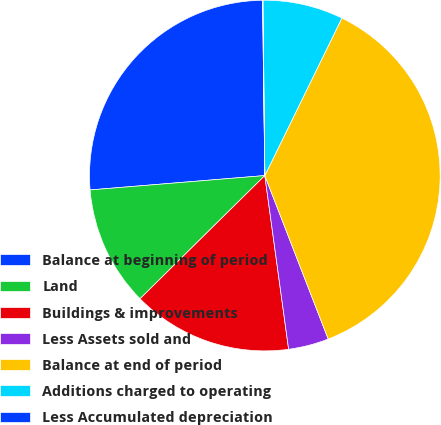<chart> <loc_0><loc_0><loc_500><loc_500><pie_chart><fcel>Balance at beginning of period<fcel>Land<fcel>Buildings & improvements<fcel>Less Assets sold and<fcel>Balance at end of period<fcel>Additions charged to operating<fcel>Less Accumulated depreciation<nl><fcel>26.1%<fcel>11.09%<fcel>14.77%<fcel>3.72%<fcel>36.87%<fcel>7.41%<fcel>0.04%<nl></chart> 